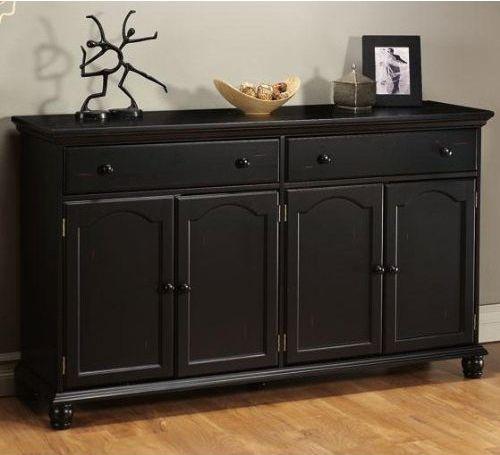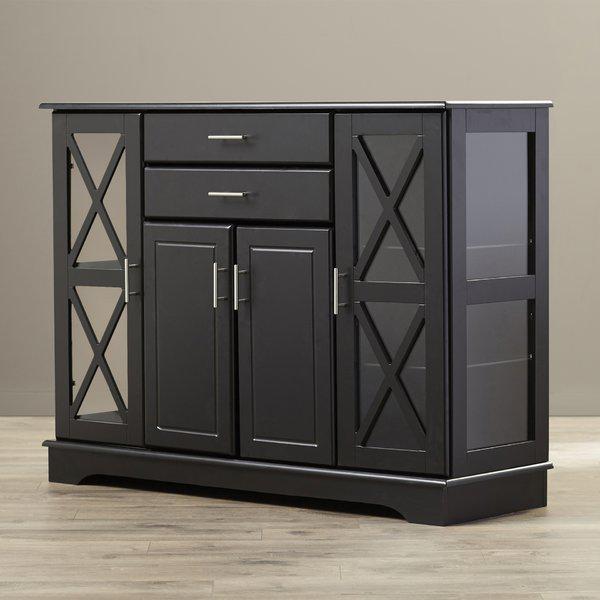The first image is the image on the left, the second image is the image on the right. Examine the images to the left and right. Is the description "At least one of the cabinets is dark and has no glass-front doors, and none of the cabinets are distinctly taller than they are wide." accurate? Answer yes or no. Yes. The first image is the image on the left, the second image is the image on the right. For the images shown, is this caption "A tall, wide wooden hutch has an upper section with at least three doors that sits directly on a lower section with two panel doors and at least three drawers." true? Answer yes or no. No. 